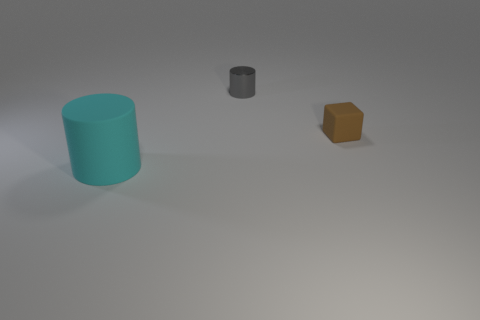Add 2 small gray cylinders. How many objects exist? 5 Subtract all cylinders. How many objects are left? 1 Subtract 0 brown spheres. How many objects are left? 3 Subtract all large shiny cylinders. Subtract all big cyan cylinders. How many objects are left? 2 Add 1 small matte blocks. How many small matte blocks are left? 2 Add 2 cyan rubber objects. How many cyan rubber objects exist? 3 